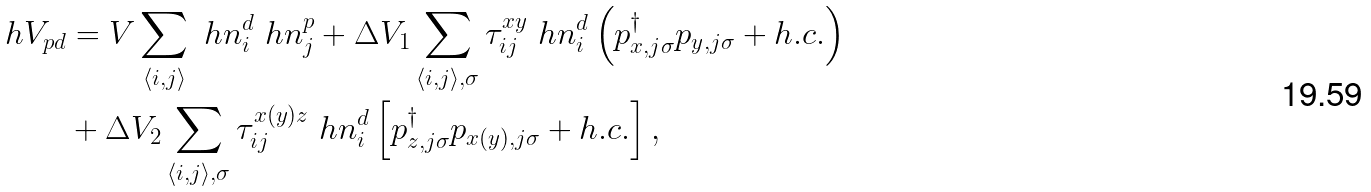<formula> <loc_0><loc_0><loc_500><loc_500>\ h V _ { p d } & = V \sum _ { \langle i , j \rangle } \ h n _ { i } ^ { d } \ h n _ { j } ^ { p } + \Delta V _ { 1 } \sum _ { \langle i , j \rangle , \sigma } \tau _ { i j } ^ { x y } \ h n _ { i } ^ { d } \left ( p _ { x , j \sigma } ^ { \dagger } p _ { y , j \sigma } + h . c . \right ) \\ & + \Delta V _ { 2 } \sum _ { \langle i , j \rangle , \sigma } \tau _ { i j } ^ { x ( y ) z } \ h n _ { i } ^ { d } \left [ p _ { z , j \sigma } ^ { \dagger } p _ { x ( y ) , j \sigma } + h . c . \right ] ,</formula> 